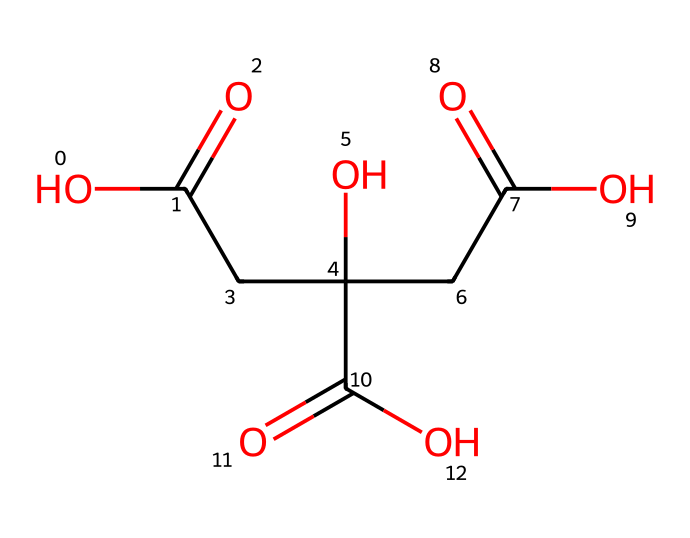how many carbon atoms are present in citric acid? The SMILES representation shows that there are three distinct carbon atoms in the chain and additional carbons in the carboxylic acid groups, totaling six.
Answer: six how many hydroxyl groups does citric acid have? In the SMILES structure, the notation "O" indicates hydroxyl groups. By counting, there are three hydroxyl groups present.
Answer: three what type of functional groups are featured in citric acid? The presence of "C(=O)" indicates carboxylic acid functional groups, and "O" represents hydroxyl functional groups. Thus, both carboxylic acid and hydroxyl groups are present.
Answer: carboxylic acid, hydroxyl what is the effect of citric acid as a natural preservative in fruit products? Citric acid acts as an antioxidant, which prevents oxidation and spoilage of the fruit products, extending their shelf life.
Answer: antioxidant how does the presence of multiple carboxylic acid groups affect the stability of citric acid? The multiple carboxylic acid groups in the structure enhance the ability to donate protons, making citric acid a more effective preservative and acidic stabilizer in food products.
Answer: enhances stability what role do the structural features of citric acid play in its antioxidant properties? The hydroxyl groups and carboxylic acid groups contribute to the ability of citric acid to donate electrons and scavenge free radicals, which is key to its function as an antioxidant.
Answer: electron donation how does citric acid's structure contribute to its solubility in water? The presence of multiple hydroxyl and carboxylic acid groups increases hydrogen bonding, enhancing citric acid's solubility in water.
Answer: increases solubility 